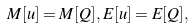<formula> <loc_0><loc_0><loc_500><loc_500>M [ u ] = M [ Q ] , \, E [ u ] = E [ Q ] ,</formula> 